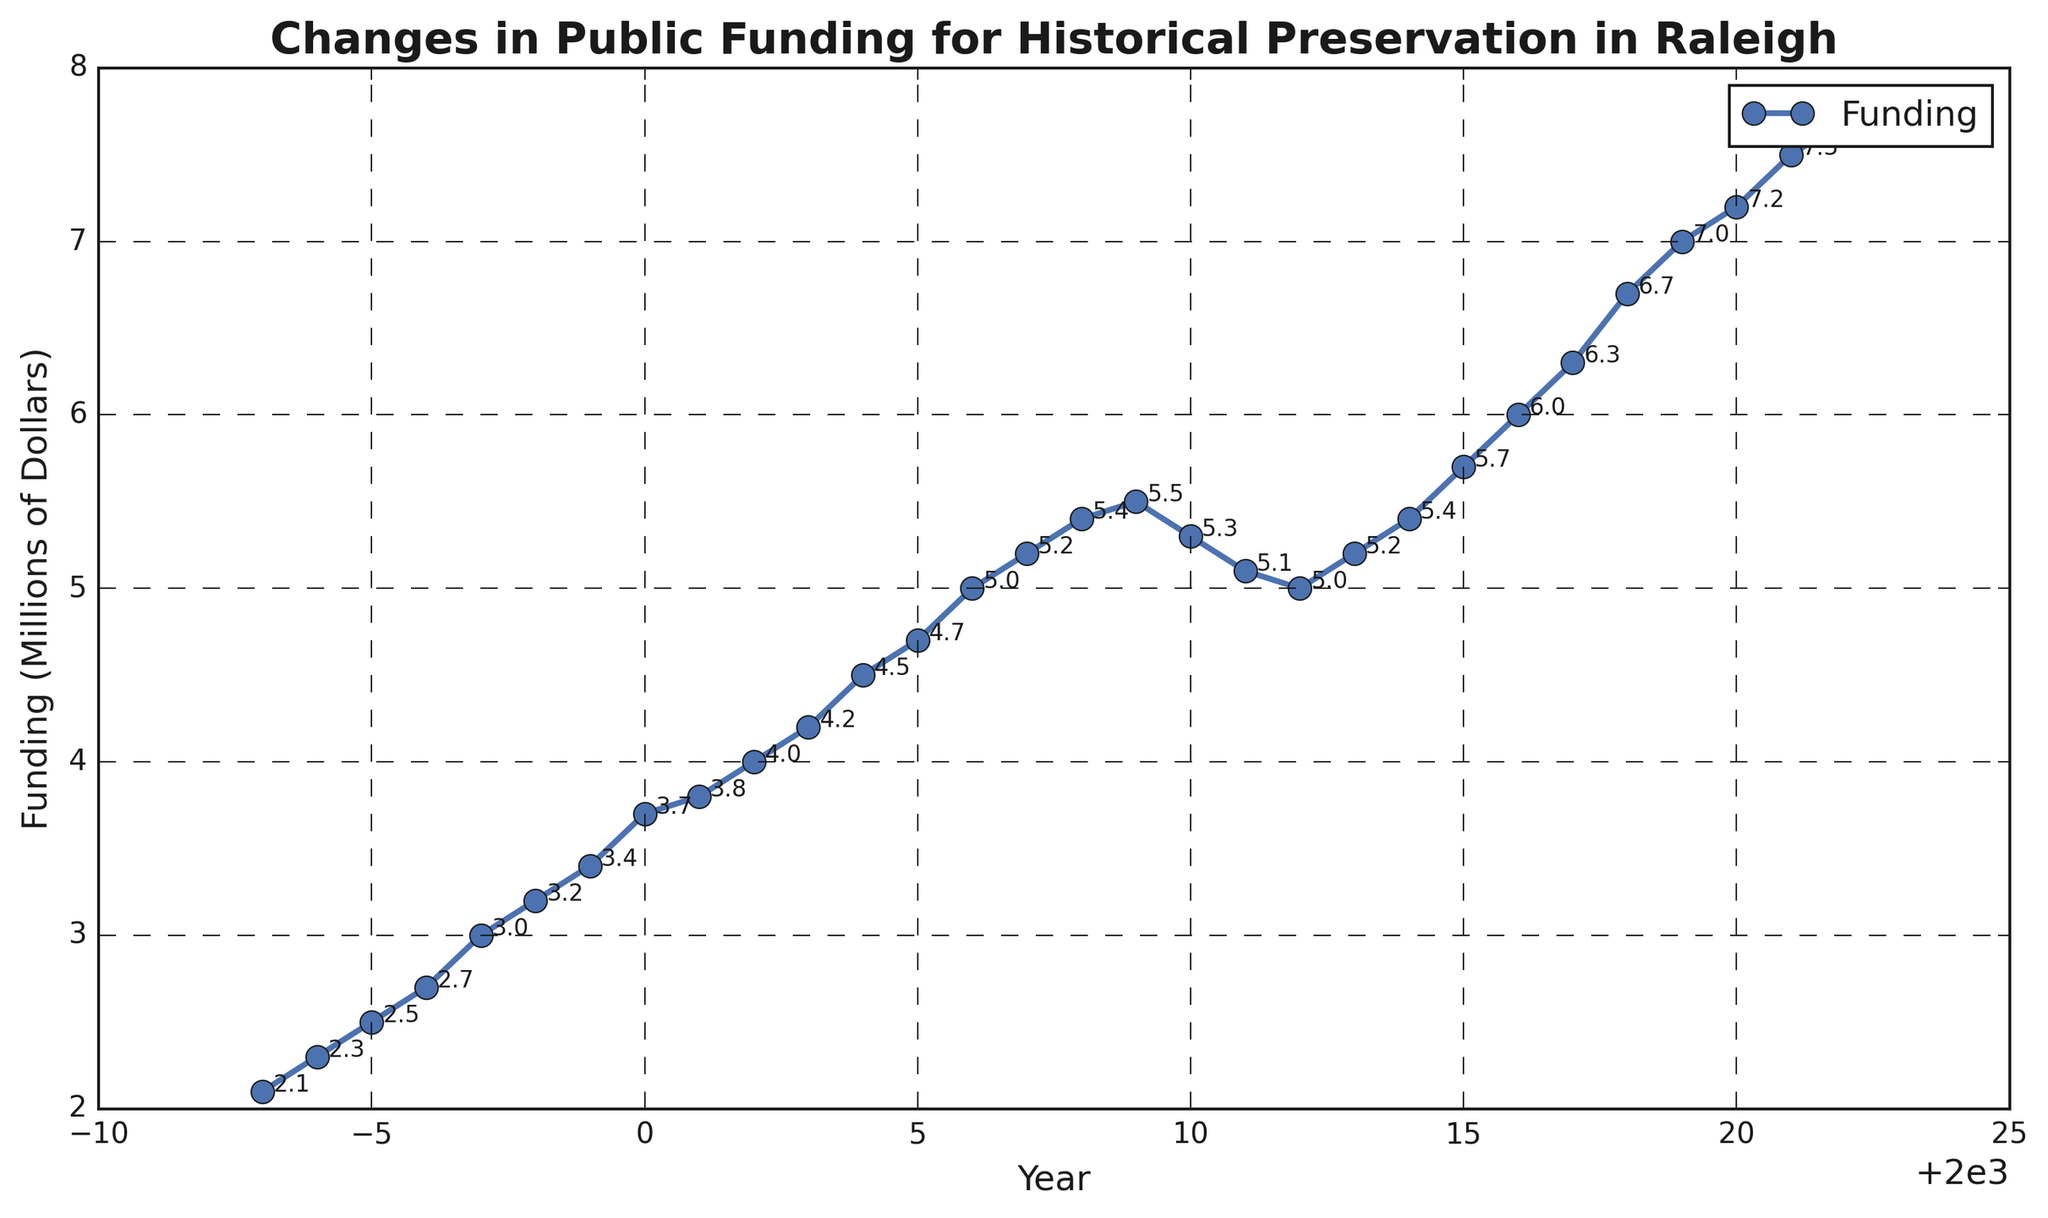What is the overall trend in public funding for historical preservation from 1993 to 2022? Observing the line, funding consistently increases, particularly from 1993 to 2009, then fluctuates until 2012, and rises again through 2022.
Answer: Increasing In which year did public funding first reach $5 million? Locate the point at $5 million on the y-axis and trace it horizontally to intersect with the year on the x-axis. This intersection falls around 2006.
Answer: 2006 How does the funding in 2022 compare to the funding in 2014? Look at the funding points for 2022 and 2014. The funding in 2022 is $7.7 million and in 2014 is $5.4 million. $7.7 million is greater than $5.4 million.
Answer: 2022 is higher What is the average annual funding increase from 1993 to 2000? Calculate the total increase: $3.7M (2000) - $2.1M (1993) = $1.6M, then divide by the number of years: $1.6M / 7 years ≈ $0.23M per year.
Answer: $0.23M per year Which period had the most significant decrease in funding? Identify dips in the line. The largest drop is between 2009 and 2012: from $5.5M to $5.0M, which is a decrease of $0.5M over three years.
Answer: 2009-2012 By how much did funding increase from 2010 to 2022? Find the funding difference for these years. 2022 ($7.7M) - 2010 ($5.3M) = $2.4M increase.
Answer: $2.4M What is the total amount of public funding given over the three decades? Sum all the individual yearly fundings from 1993 to 2022. This sum must be calculated individually and totaled.
Answer: $152.5M Is the funding trend between 2018 and 2022 increasing, decreasing, or stable? Reviewing these specific years, funding rises from $6.7M (2018) to $7.7M (2022), showing an increasing trend.
Answer: Increasing What was the funding amount in 2003, and how does it compare to 2004? Find the funding points. 2003 ($4.2M) and 2004 ($4.5M). 2004 is higher by $0.3M.
Answer: $4.2M in 2003, less by $0.3M than 2004 